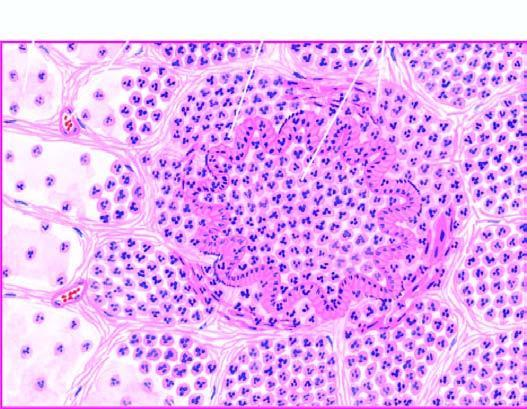why are the alveolar septa thickened?
Answer the question using a single word or phrase. Due to congested capillaries and neutrophilic infiltrate 